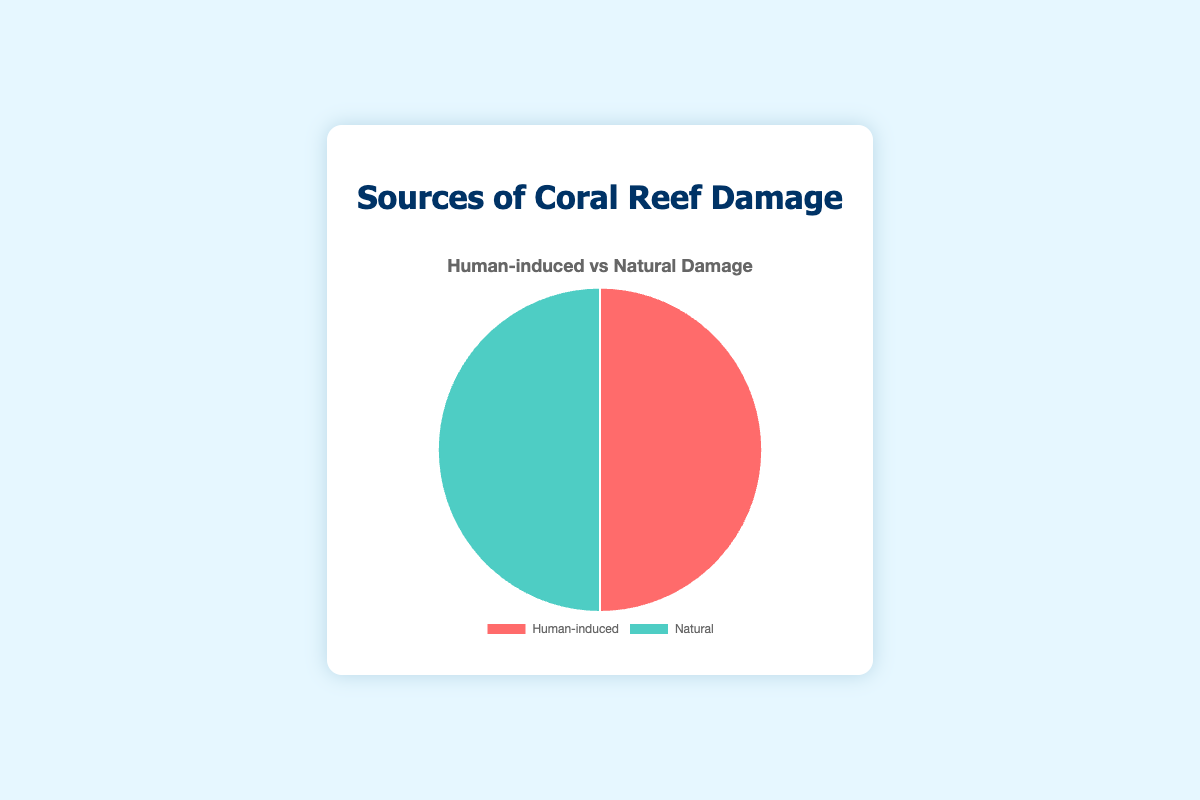Which source of damage is represented by the red color? The pie chart uses a specific color for each damage source. The red color represents "Human-induced" damage as per the visual information provided.
Answer: Human-induced Which section of the pie chart is larger, Human-induced or Natural? By visually comparing the sizes of the two sections in the pie chart, we can see they are equally large.
Answer: They are equal If the total damage was 200 units, how many units would correspond to Human-induced damage? Since both segments in the pie chart are equal, each one represents half of the total damage. Thus, we can calculate the Human-induced damage as 200 / 2 = 100 units.
Answer: 100 units What is the difference in the number of units between Storm Damage and Overfishing? Storm Damage is a natural cause with 40 units and Overfishing is a human-induced cause with 25 units. The difference is 40 - 25 = 15 units.
Answer: 15 units What percentage of Human-induced damage is caused by Climate Change? To find the percentage, divide the units of Climate Change by the total Human-induced damage units and multiply by 100: (30 / 100) * 100 = 30%.
Answer: 30% How does the total damage caused by Predation by Crown-of-Thorns Starfish compare to that caused by Tourism? Predation by Crown-of-Thorns Starfish causes 30 units of damage while Tourism causes 10 units. 30 is 3 times 10, so the Starfish causes three times the damage as Tourism.
Answer: 3 times more What is the combined damage caused by Diseases and Temperature Fluctuations in the Natural category? Diseases cause 20 units of damage and Temperature Fluctuations cause 10 units. The total combined damage is 20 + 10 = 30 units.
Answer: 30 units Which specific human-induced activity contributes the most to coral reef damage? According to the data, Climate Change, a human-induced activity, contributes the most with 30 units.
Answer: Climate Change 